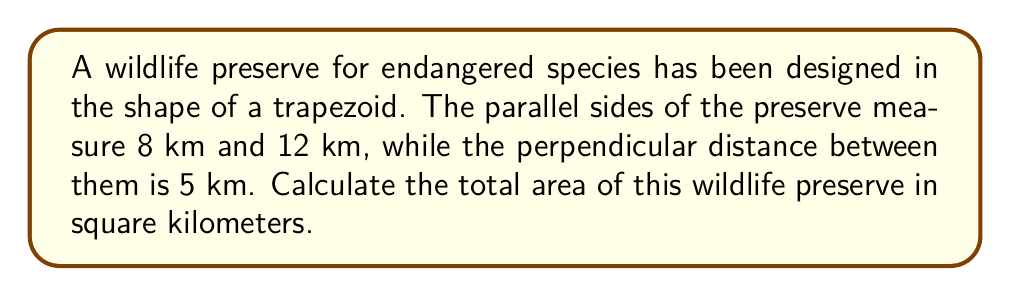Show me your answer to this math problem. To solve this problem, we'll use the formula for the area of a trapezoid:

$$A = \frac{1}{2}(b_1 + b_2)h$$

Where:
$A$ = Area
$b_1$ and $b_2$ = Lengths of the parallel sides
$h$ = Height (perpendicular distance between parallel sides)

Given:
$b_1 = 8$ km
$b_2 = 12$ km
$h = 5$ km

Let's substitute these values into the formula:

$$A = \frac{1}{2}(8 + 12) \cdot 5$$

Simplify inside the parentheses:
$$A = \frac{1}{2}(20) \cdot 5$$

Multiply:
$$A = 10 \cdot 5 = 50$$

Therefore, the area of the wildlife preserve is 50 square kilometers.

[asy]
unitsize(1cm);
pair A=(0,0), B=(12,0), C=(9,5), D=(3,5);
draw(A--B--C--D--cycle);
label("8 km", (D--A), W);
label("12 km", (B--C), E);
label("5 km", (0,2.5), W);
[/asy]
Answer: $50$ km² 